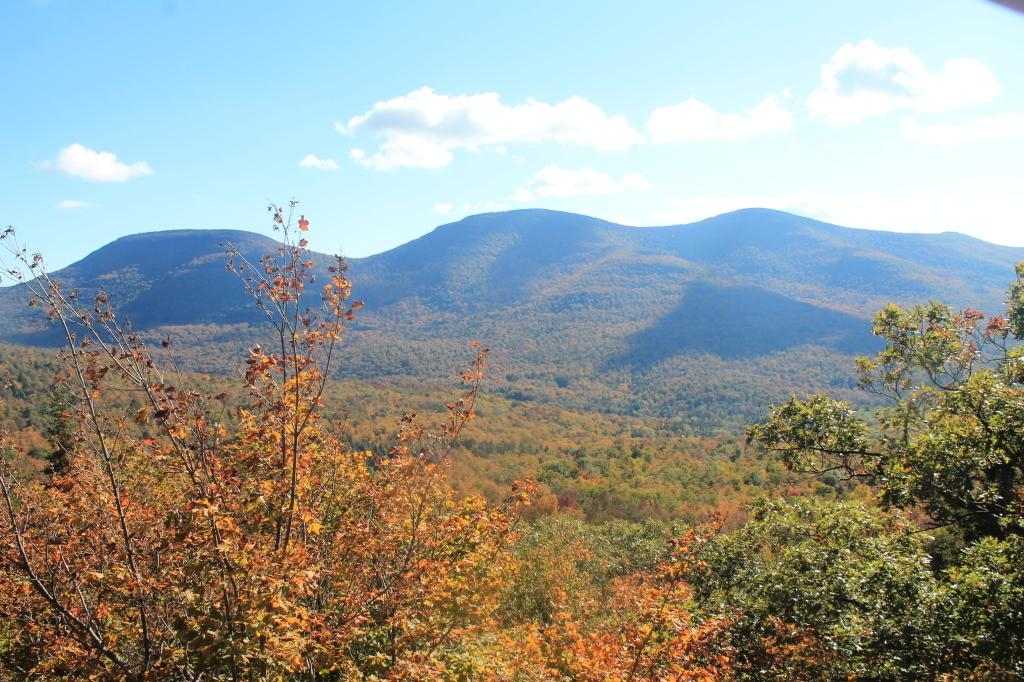What type of vegetation is present in the image? There are green color trees in the image. What part of the natural environment is visible in the image? The sky is visible in the image. Where is the map located in the image? There is no map present in the image. What type of creature might be holding a stick in the image? There is no creature or stick present in the image. 